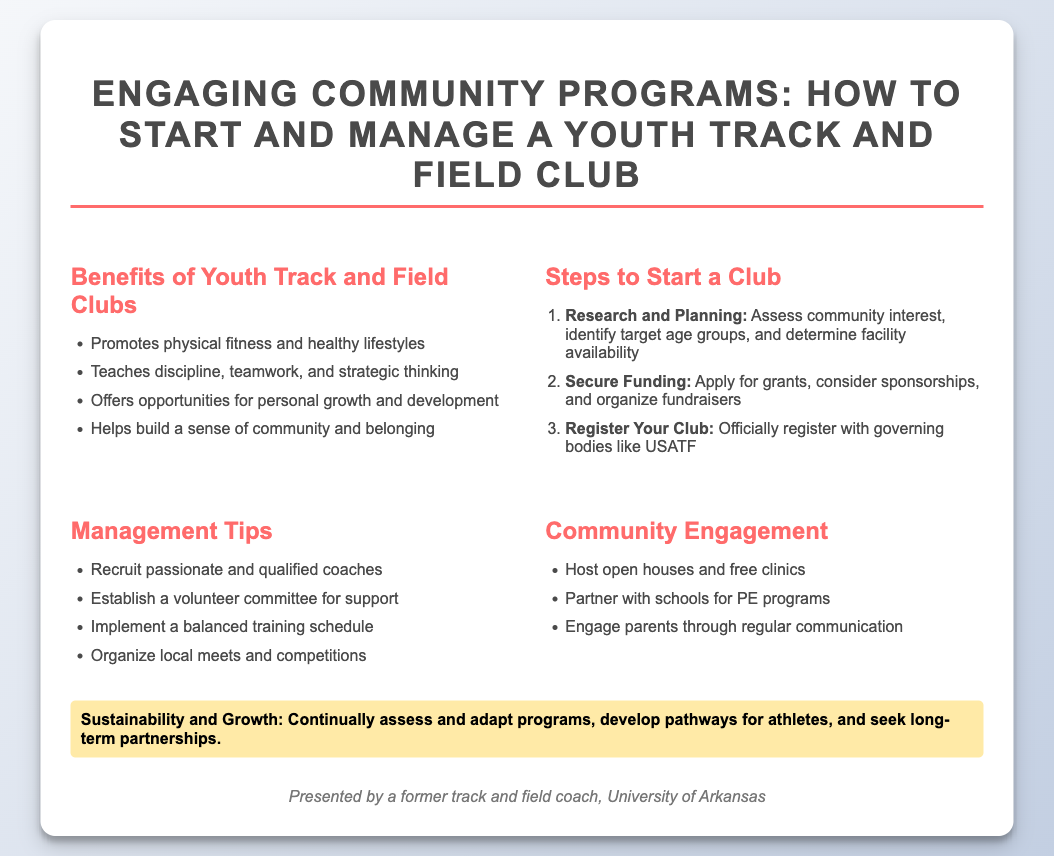What are the benefits of youth track and field clubs? The document lists four benefits, including promoting physical fitness and healthy lifestyles.
Answer: Promotes physical fitness and healthy lifestyles How many steps are outlined to start a club? The document outlines three specific steps in the "Steps to Start a Club" section.
Answer: Three What should you do first to start a club? The first step listed is "Research and Planning," which involves assessing community interest.
Answer: Research and Planning What is one management tip mentioned in the document? The document mentions multiple management tips, one being to recruit passionate and qualified coaches.
Answer: Recruit passionate and qualified coaches What type of events can help engage the community? The document mentions hosting open houses and free clinics as a means of community engagement.
Answer: Host open houses and free clinics Who presented the information? The footer of the document attributes the presentation to a former track and field coach.
Answer: A former track and field coach What does the highlight section emphasize? The highlight section emphasizes sustainability and growth in managing the club.
Answer: Sustainability and Growth What organization should the club register with? The document specifies registering with governing bodies like USATF.
Answer: USATF What is one way to partner with schools? The document suggests partnering with schools for PE programs as a way to engage with younger athletes.
Answer: Partner with schools for PE programs 